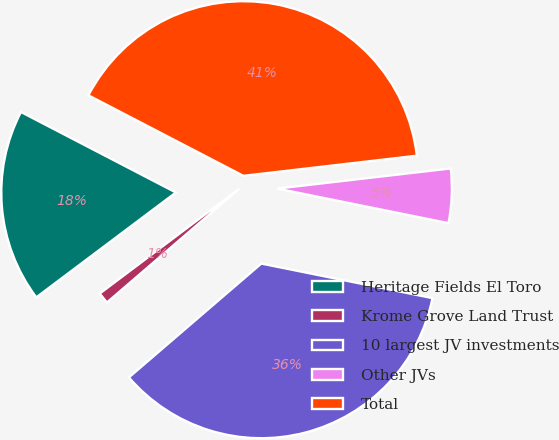Convert chart to OTSL. <chart><loc_0><loc_0><loc_500><loc_500><pie_chart><fcel>Heritage Fields El Toro<fcel>Krome Grove Land Trust<fcel>10 largest JV investments<fcel>Other JVs<fcel>Total<nl><fcel>17.88%<fcel>1.05%<fcel>35.53%<fcel>5.01%<fcel>40.54%<nl></chart> 